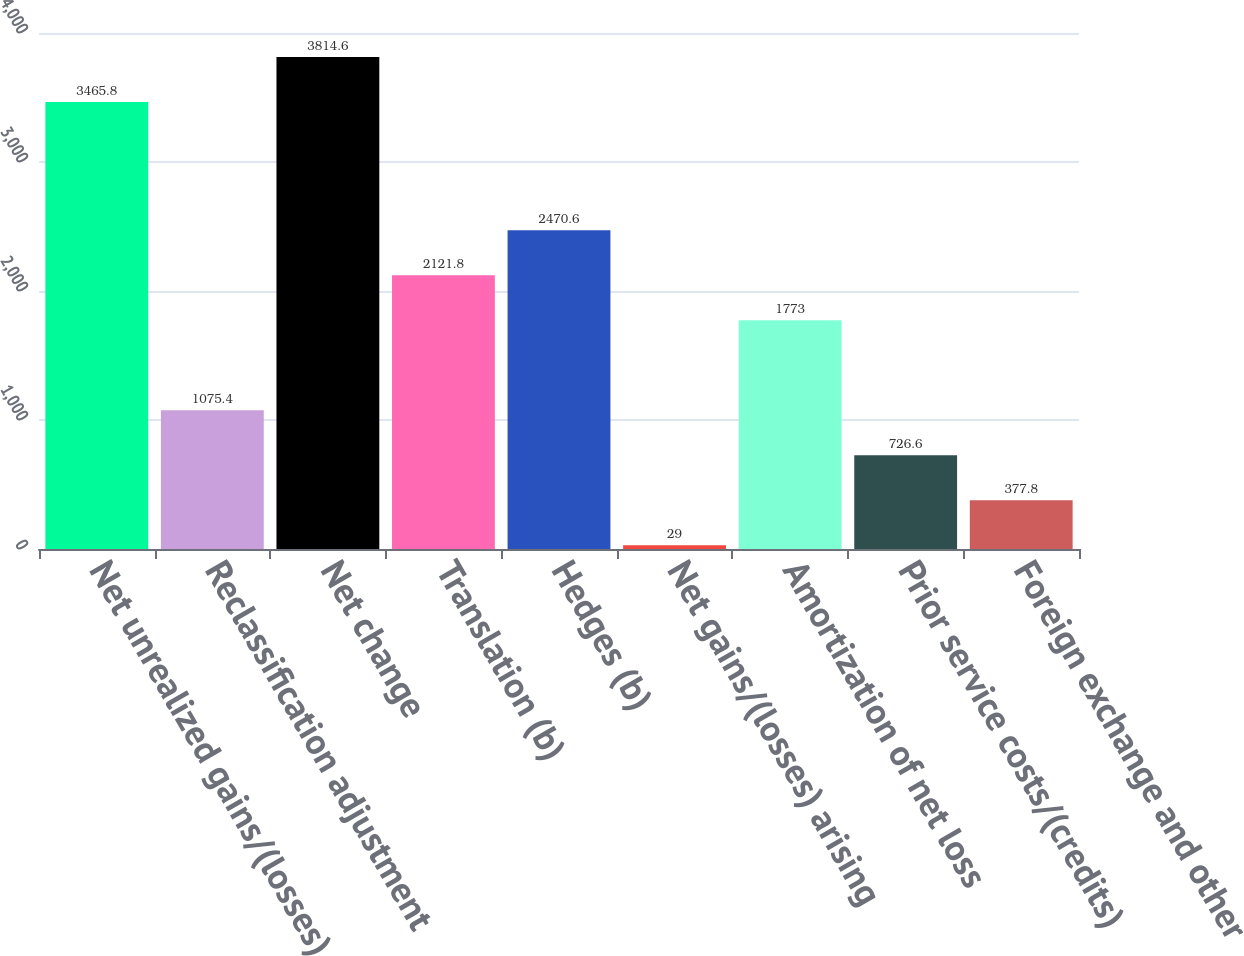<chart> <loc_0><loc_0><loc_500><loc_500><bar_chart><fcel>Net unrealized gains/(losses)<fcel>Reclassification adjustment<fcel>Net change<fcel>Translation (b)<fcel>Hedges (b)<fcel>Net gains/(losses) arising<fcel>Amortization of net loss<fcel>Prior service costs/(credits)<fcel>Foreign exchange and other<nl><fcel>3465.8<fcel>1075.4<fcel>3814.6<fcel>2121.8<fcel>2470.6<fcel>29<fcel>1773<fcel>726.6<fcel>377.8<nl></chart> 